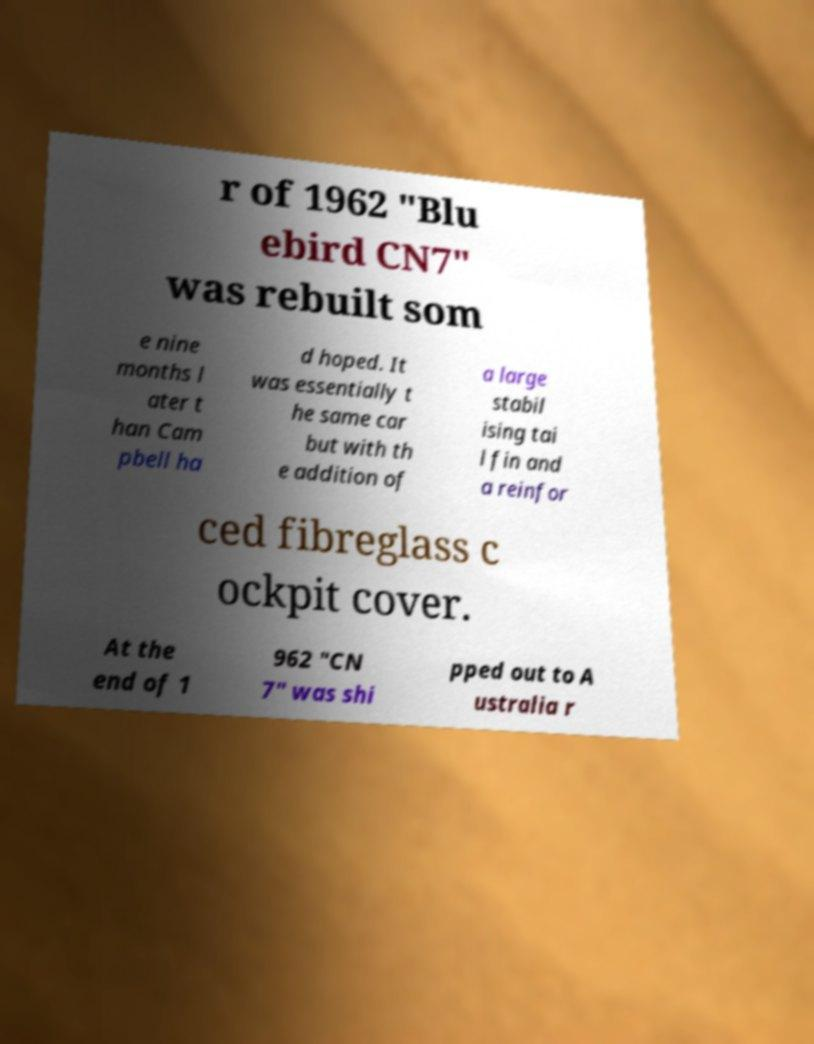Can you accurately transcribe the text from the provided image for me? r of 1962 "Blu ebird CN7" was rebuilt som e nine months l ater t han Cam pbell ha d hoped. It was essentially t he same car but with th e addition of a large stabil ising tai l fin and a reinfor ced fibreglass c ockpit cover. At the end of 1 962 "CN 7" was shi pped out to A ustralia r 